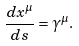Convert formula to latex. <formula><loc_0><loc_0><loc_500><loc_500>\frac { d x ^ { \mu } } { d s } = \gamma ^ { \mu } .</formula> 